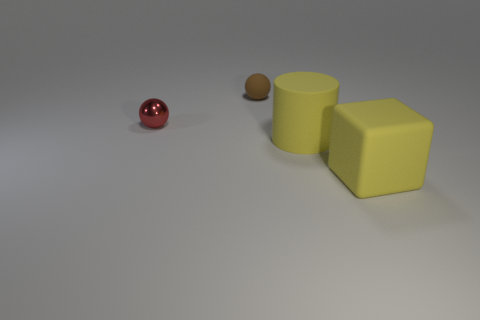Add 1 yellow rubber cubes. How many objects exist? 5 Subtract all cylinders. How many objects are left? 3 Subtract all tiny red things. Subtract all large matte things. How many objects are left? 1 Add 1 large yellow cubes. How many large yellow cubes are left? 2 Add 3 tiny brown shiny blocks. How many tiny brown shiny blocks exist? 3 Subtract 0 green blocks. How many objects are left? 4 